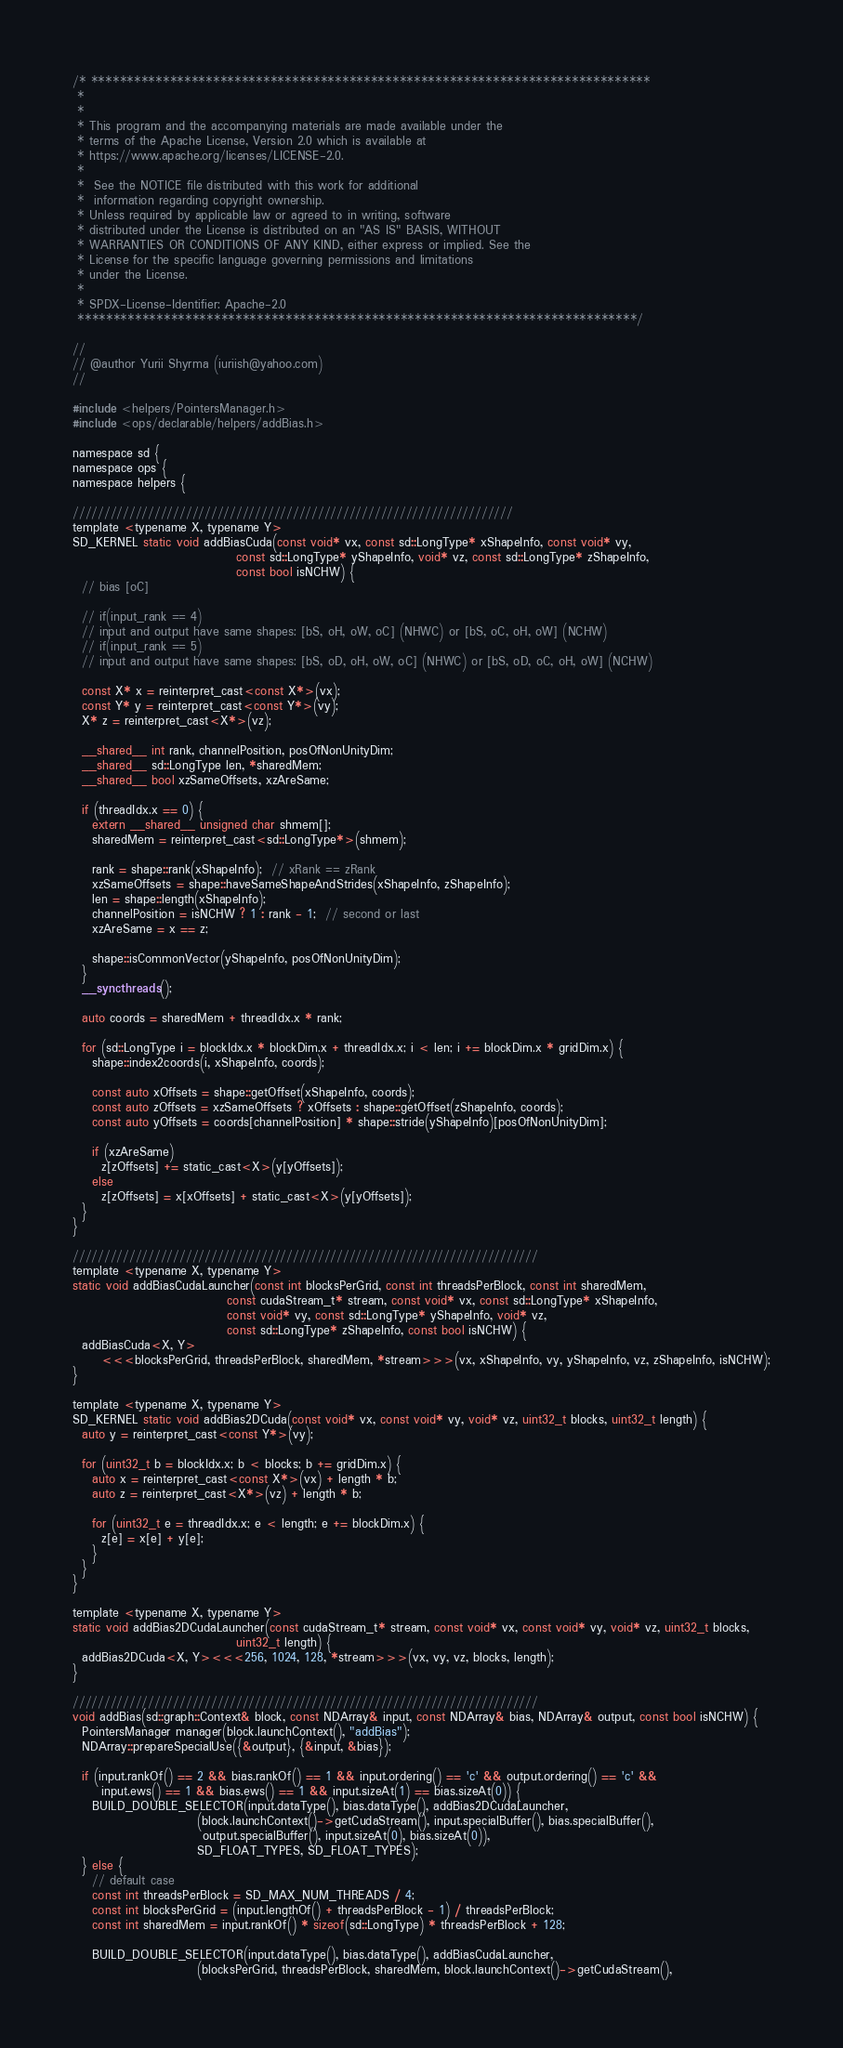<code> <loc_0><loc_0><loc_500><loc_500><_Cuda_>/* ******************************************************************************
 *
 *
 * This program and the accompanying materials are made available under the
 * terms of the Apache License, Version 2.0 which is available at
 * https://www.apache.org/licenses/LICENSE-2.0.
 *
 *  See the NOTICE file distributed with this work for additional
 *  information regarding copyright ownership.
 * Unless required by applicable law or agreed to in writing, software
 * distributed under the License is distributed on an "AS IS" BASIS, WITHOUT
 * WARRANTIES OR CONDITIONS OF ANY KIND, either express or implied. See the
 * License for the specific language governing permissions and limitations
 * under the License.
 *
 * SPDX-License-Identifier: Apache-2.0
 ******************************************************************************/

//
// @author Yurii Shyrma (iuriish@yahoo.com)
//

#include <helpers/PointersManager.h>
#include <ops/declarable/helpers/addBias.h>

namespace sd {
namespace ops {
namespace helpers {

//////////////////////////////////////////////////////////////////////
template <typename X, typename Y>
SD_KERNEL static void addBiasCuda(const void* vx, const sd::LongType* xShapeInfo, const void* vy,
                                  const sd::LongType* yShapeInfo, void* vz, const sd::LongType* zShapeInfo,
                                  const bool isNCHW) {
  // bias [oC]

  // if(input_rank == 4)
  // input and output have same shapes: [bS, oH, oW, oC] (NHWC) or [bS, oC, oH, oW] (NCHW)
  // if(input_rank == 5)
  // input and output have same shapes: [bS, oD, oH, oW, oC] (NHWC) or [bS, oD, oC, oH, oW] (NCHW)

  const X* x = reinterpret_cast<const X*>(vx);
  const Y* y = reinterpret_cast<const Y*>(vy);
  X* z = reinterpret_cast<X*>(vz);

  __shared__ int rank, channelPosition, posOfNonUnityDim;
  __shared__ sd::LongType len, *sharedMem;
  __shared__ bool xzSameOffsets, xzAreSame;

  if (threadIdx.x == 0) {
    extern __shared__ unsigned char shmem[];
    sharedMem = reinterpret_cast<sd::LongType*>(shmem);

    rank = shape::rank(xShapeInfo);  // xRank == zRank
    xzSameOffsets = shape::haveSameShapeAndStrides(xShapeInfo, zShapeInfo);
    len = shape::length(xShapeInfo);
    channelPosition = isNCHW ? 1 : rank - 1;  // second or last
    xzAreSame = x == z;

    shape::isCommonVector(yShapeInfo, posOfNonUnityDim);
  }
  __syncthreads();

  auto coords = sharedMem + threadIdx.x * rank;

  for (sd::LongType i = blockIdx.x * blockDim.x + threadIdx.x; i < len; i += blockDim.x * gridDim.x) {
    shape::index2coords(i, xShapeInfo, coords);

    const auto xOffsets = shape::getOffset(xShapeInfo, coords);
    const auto zOffsets = xzSameOffsets ? xOffsets : shape::getOffset(zShapeInfo, coords);
    const auto yOffsets = coords[channelPosition] * shape::stride(yShapeInfo)[posOfNonUnityDim];

    if (xzAreSame)
      z[zOffsets] += static_cast<X>(y[yOffsets]);
    else
      z[zOffsets] = x[xOffsets] + static_cast<X>(y[yOffsets]);
  }
}

//////////////////////////////////////////////////////////////////////////
template <typename X, typename Y>
static void addBiasCudaLauncher(const int blocksPerGrid, const int threadsPerBlock, const int sharedMem,
                                const cudaStream_t* stream, const void* vx, const sd::LongType* xShapeInfo,
                                const void* vy, const sd::LongType* yShapeInfo, void* vz,
                                const sd::LongType* zShapeInfo, const bool isNCHW) {
  addBiasCuda<X, Y>
      <<<blocksPerGrid, threadsPerBlock, sharedMem, *stream>>>(vx, xShapeInfo, vy, yShapeInfo, vz, zShapeInfo, isNCHW);
}

template <typename X, typename Y>
SD_KERNEL static void addBias2DCuda(const void* vx, const void* vy, void* vz, uint32_t blocks, uint32_t length) {
  auto y = reinterpret_cast<const Y*>(vy);

  for (uint32_t b = blockIdx.x; b < blocks; b += gridDim.x) {
    auto x = reinterpret_cast<const X*>(vx) + length * b;
    auto z = reinterpret_cast<X*>(vz) + length * b;

    for (uint32_t e = threadIdx.x; e < length; e += blockDim.x) {
      z[e] = x[e] + y[e];
    }
  }
}

template <typename X, typename Y>
static void addBias2DCudaLauncher(const cudaStream_t* stream, const void* vx, const void* vy, void* vz, uint32_t blocks,
                                  uint32_t length) {
  addBias2DCuda<X, Y><<<256, 1024, 128, *stream>>>(vx, vy, vz, blocks, length);
}

//////////////////////////////////////////////////////////////////////////
void addBias(sd::graph::Context& block, const NDArray& input, const NDArray& bias, NDArray& output, const bool isNCHW) {
  PointersManager manager(block.launchContext(), "addBias");
  NDArray::prepareSpecialUse({&output}, {&input, &bias});

  if (input.rankOf() == 2 && bias.rankOf() == 1 && input.ordering() == 'c' && output.ordering() == 'c' &&
      input.ews() == 1 && bias.ews() == 1 && input.sizeAt(1) == bias.sizeAt(0)) {
    BUILD_DOUBLE_SELECTOR(input.dataType(), bias.dataType(), addBias2DCudaLauncher,
                          (block.launchContext()->getCudaStream(), input.specialBuffer(), bias.specialBuffer(),
                           output.specialBuffer(), input.sizeAt(0), bias.sizeAt(0)),
                          SD_FLOAT_TYPES, SD_FLOAT_TYPES);
  } else {
    // default case
    const int threadsPerBlock = SD_MAX_NUM_THREADS / 4;
    const int blocksPerGrid = (input.lengthOf() + threadsPerBlock - 1) / threadsPerBlock;
    const int sharedMem = input.rankOf() * sizeof(sd::LongType) * threadsPerBlock + 128;

    BUILD_DOUBLE_SELECTOR(input.dataType(), bias.dataType(), addBiasCudaLauncher,
                          (blocksPerGrid, threadsPerBlock, sharedMem, block.launchContext()->getCudaStream(),</code> 